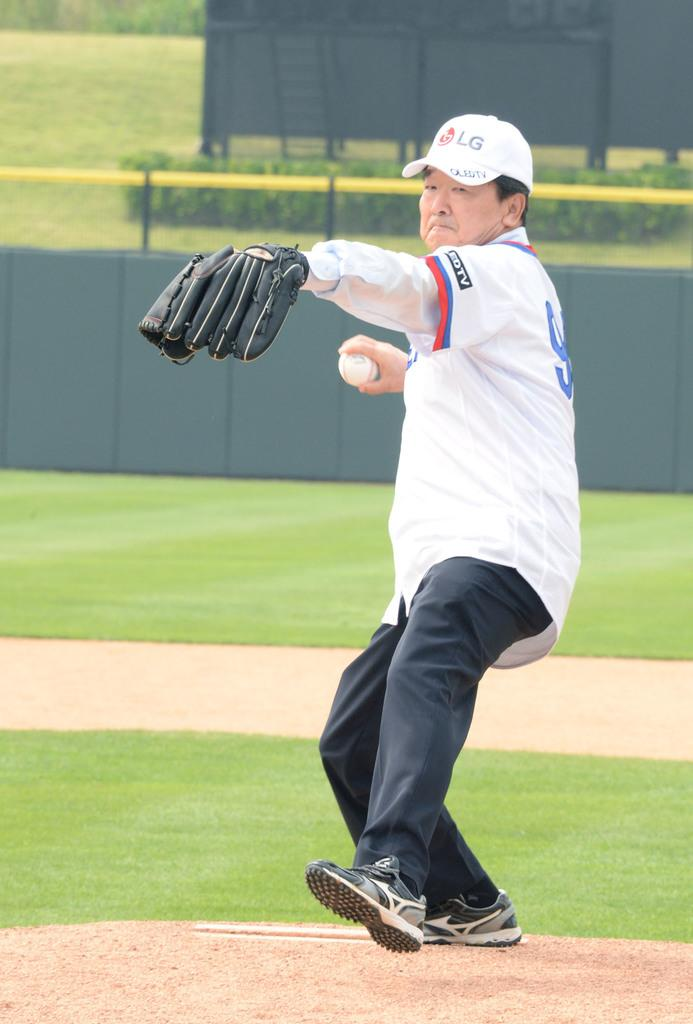<image>
Offer a succinct explanation of the picture presented. A pitcher wearing an LG hat gets ready to throw the ball 